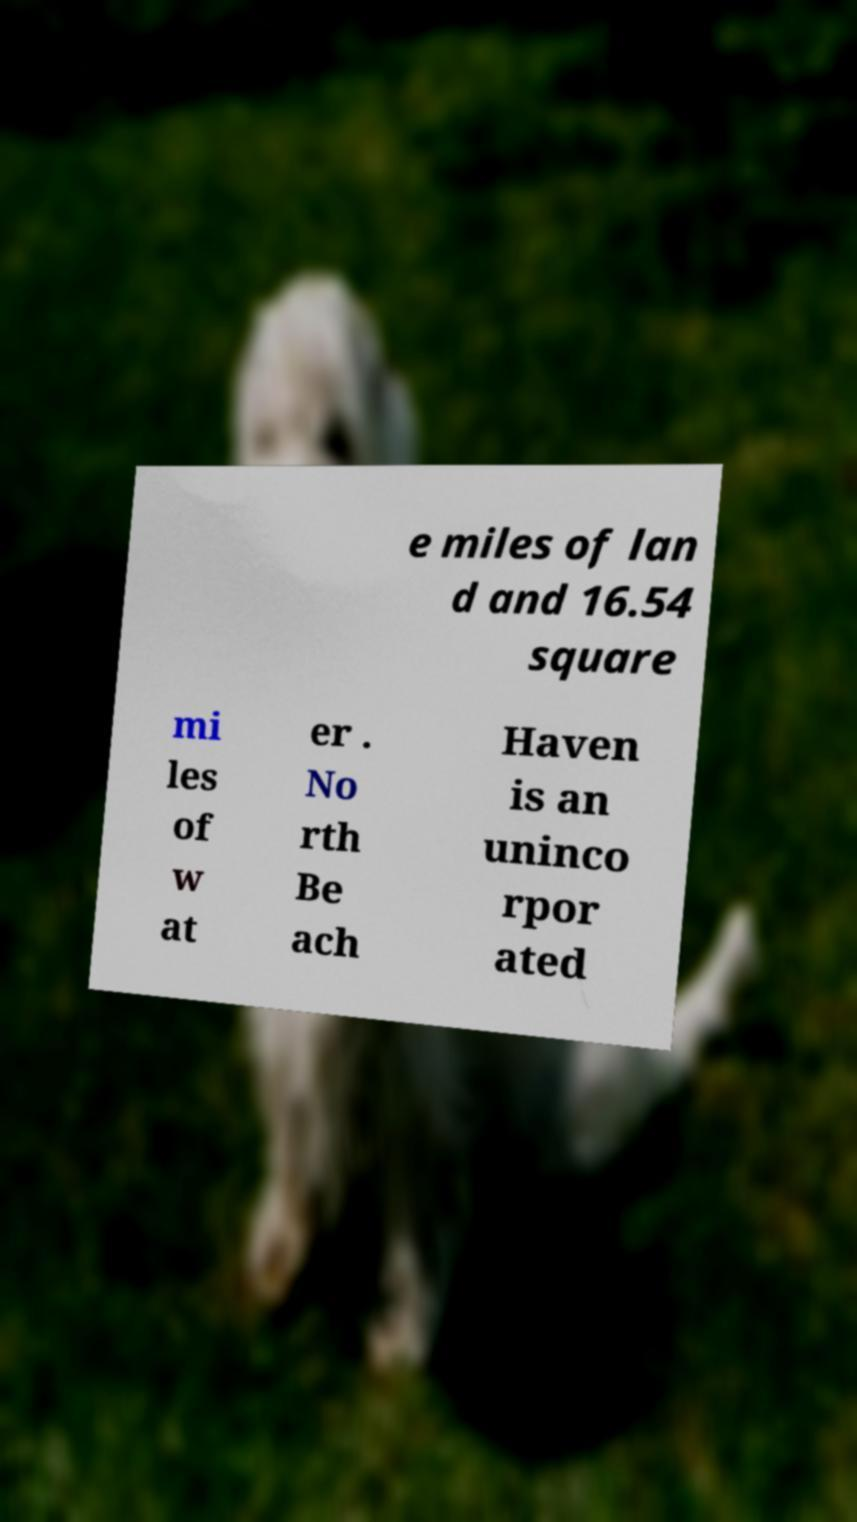For documentation purposes, I need the text within this image transcribed. Could you provide that? e miles of lan d and 16.54 square mi les of w at er . No rth Be ach Haven is an uninco rpor ated 